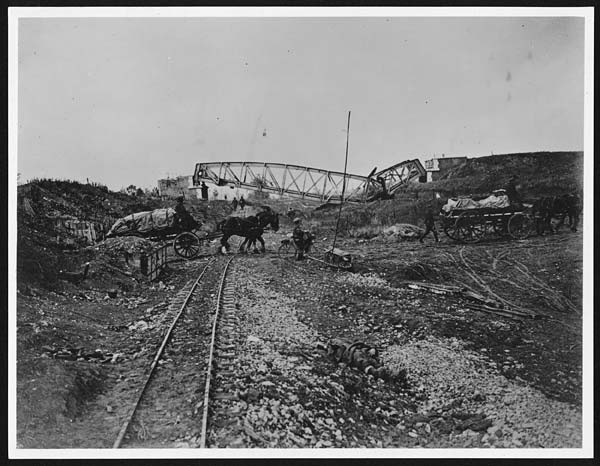What would it be like if a modern-day engineer visited the construction site depicted in the image? If a modern-day engineer were to visit the construction site in the image, they would likely be struck by the stark differences in technology, safety protocols, and work conditions. The engineer might marvel at the sheer determination and physical endurance of the workers, employing basic tools and manual labor to accomplish monumental tasks that today would be handled by advanced machinery. They would note the lack of personal protective equipment and express concern over the safety standards of the time. Additionally, the engineer would be impressed by the ingenuity and resourcefulness of the workers, recognizing that despite the primitive conditions, significant progress was being made. This visit would underscore the profound advancements in engineering and labor conditions over the past century. How do you think the presence of horse-drawn carriages impacts the efficiency of the construction work? The presence of horse-drawn carriages in the construction site likely played a dual role. On one hand, they were essential for transporting materials and tools over uneven and difficult terrain where mechanized vehicles would struggle. On the other hand, their speed and load capacity were limited compared to modern machinery, potentially slowing down the overall pace of construction. Horses also required regular care and feeding, adding to the logistical challenges faced by the workers. Despite these limitations, horse-drawn carriages were a crucial asset, showcasing the ways in which contemporary technology was harnessed to accomplish large-scale infrastructure projects.  What if this image was taken on Mars, and the workers are actually constructing the first railway on the Martian surface? Imagine this: Against the rusty, red backdrop of the Martian terrain, workers clad in high-tech spacesuits toil under the dim, alien sky. The horse carriages are replaced by sleek rovers that glide across the rocky surface, transporting materials imported from Earth. Massive, domed structures shield the workers from the harsh Martian atmosphere as they lay down tracks for what will become the first railway on Mars. This ambitious project is backed by an international coalition dedicated to making Mars habitable. Each day is a blend of rigorous scientific endeavor and hard physical labor. The construction of the Martian railway is a symbol of humanity's unyielding spirit of exploration and innovation, heralding a new era of interplanetary travel and colonization. 